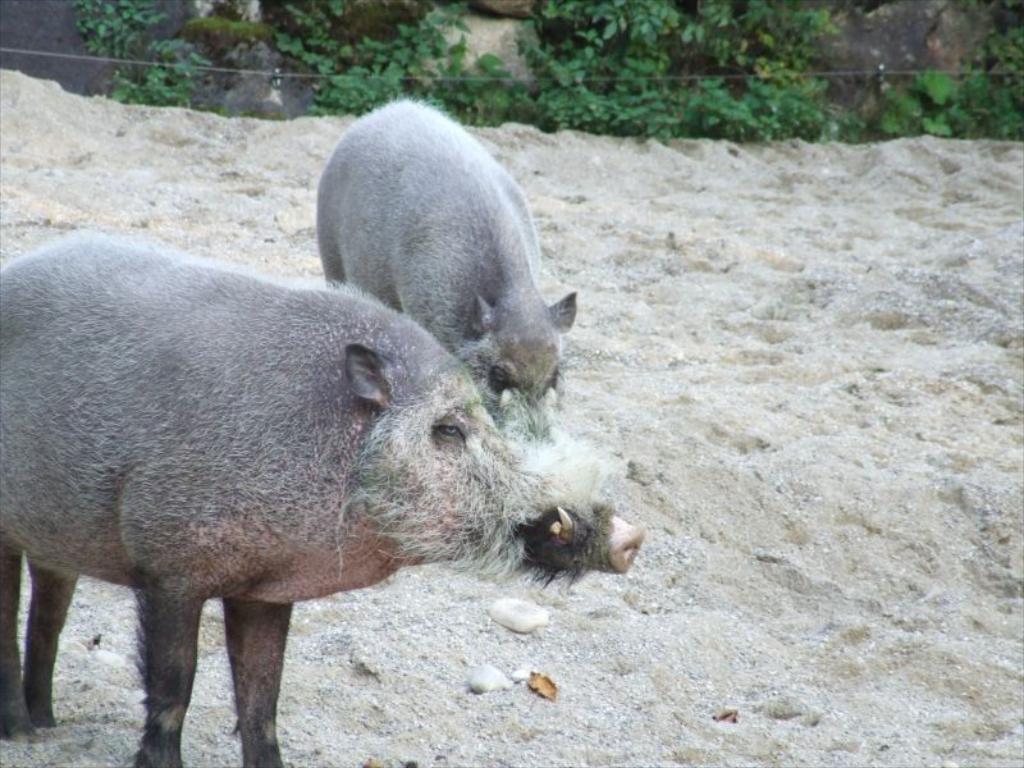Could you give a brief overview of what you see in this image? In this image I can see two pigs on the ground. In the background I can see plants and rocks. This image is taken may be during a day. 